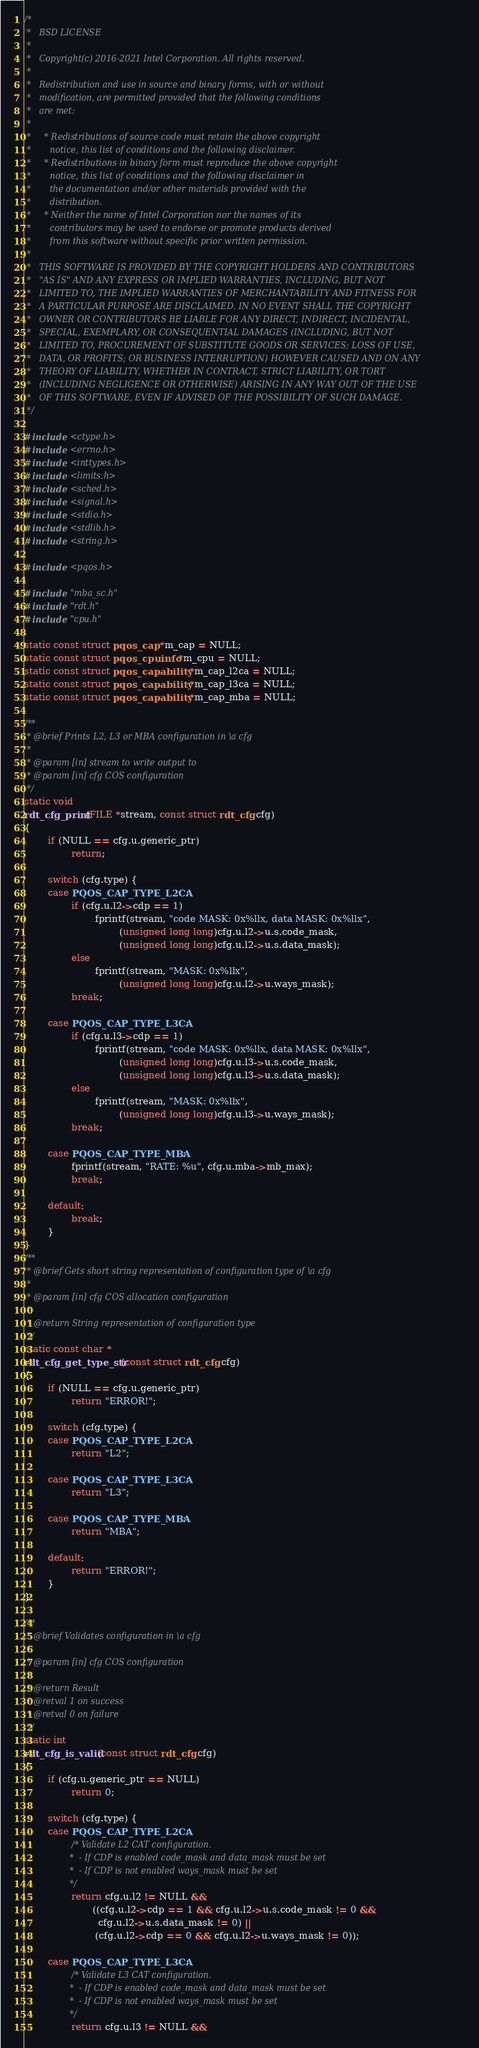Convert code to text. <code><loc_0><loc_0><loc_500><loc_500><_C_>/*
 *   BSD LICENSE
 *
 *   Copyright(c) 2016-2021 Intel Corporation. All rights reserved.
 *
 *   Redistribution and use in source and binary forms, with or without
 *   modification, are permitted provided that the following conditions
 *   are met:
 *
 *     * Redistributions of source code must retain the above copyright
 *       notice, this list of conditions and the following disclaimer.
 *     * Redistributions in binary form must reproduce the above copyright
 *       notice, this list of conditions and the following disclaimer in
 *       the documentation and/or other materials provided with the
 *       distribution.
 *     * Neither the name of Intel Corporation nor the names of its
 *       contributors may be used to endorse or promote products derived
 *       from this software without specific prior written permission.
 *
 *   THIS SOFTWARE IS PROVIDED BY THE COPYRIGHT HOLDERS AND CONTRIBUTORS
 *   "AS IS" AND ANY EXPRESS OR IMPLIED WARRANTIES, INCLUDING, BUT NOT
 *   LIMITED TO, THE IMPLIED WARRANTIES OF MERCHANTABILITY AND FITNESS FOR
 *   A PARTICULAR PURPOSE ARE DISCLAIMED. IN NO EVENT SHALL THE COPYRIGHT
 *   OWNER OR CONTRIBUTORS BE LIABLE FOR ANY DIRECT, INDIRECT, INCIDENTAL,
 *   SPECIAL, EXEMPLARY, OR CONSEQUENTIAL DAMAGES (INCLUDING, BUT NOT
 *   LIMITED TO, PROCUREMENT OF SUBSTITUTE GOODS OR SERVICES; LOSS OF USE,
 *   DATA, OR PROFITS; OR BUSINESS INTERRUPTION) HOWEVER CAUSED AND ON ANY
 *   THEORY OF LIABILITY, WHETHER IN CONTRACT, STRICT LIABILITY, OR TORT
 *   (INCLUDING NEGLIGENCE OR OTHERWISE) ARISING IN ANY WAY OUT OF THE USE
 *   OF THIS SOFTWARE, EVEN IF ADVISED OF THE POSSIBILITY OF SUCH DAMAGE.
 */

#include <ctype.h>
#include <errno.h>
#include <inttypes.h>
#include <limits.h>
#include <sched.h>
#include <signal.h>
#include <stdio.h>
#include <stdlib.h>
#include <string.h>

#include <pqos.h>

#include "mba_sc.h"
#include "rdt.h"
#include "cpu.h"

static const struct pqos_cap *m_cap = NULL;
static const struct pqos_cpuinfo *m_cpu = NULL;
static const struct pqos_capability *m_cap_l2ca = NULL;
static const struct pqos_capability *m_cap_l3ca = NULL;
static const struct pqos_capability *m_cap_mba = NULL;

/**
 * @brief Prints L2, L3 or MBA configuration in \a cfg
 *
 * @param [in] stream to write output to
 * @param [in] cfg COS configuration
 */
static void
rdt_cfg_print(FILE *stream, const struct rdt_cfg cfg)
{
        if (NULL == cfg.u.generic_ptr)
                return;

        switch (cfg.type) {
        case PQOS_CAP_TYPE_L2CA:
                if (cfg.u.l2->cdp == 1)
                        fprintf(stream, "code MASK: 0x%llx, data MASK: 0x%llx",
                                (unsigned long long)cfg.u.l2->u.s.code_mask,
                                (unsigned long long)cfg.u.l2->u.s.data_mask);
                else
                        fprintf(stream, "MASK: 0x%llx",
                                (unsigned long long)cfg.u.l2->u.ways_mask);
                break;

        case PQOS_CAP_TYPE_L3CA:
                if (cfg.u.l3->cdp == 1)
                        fprintf(stream, "code MASK: 0x%llx, data MASK: 0x%llx",
                                (unsigned long long)cfg.u.l3->u.s.code_mask,
                                (unsigned long long)cfg.u.l3->u.s.data_mask);
                else
                        fprintf(stream, "MASK: 0x%llx",
                                (unsigned long long)cfg.u.l3->u.ways_mask);
                break;

        case PQOS_CAP_TYPE_MBA:
                fprintf(stream, "RATE: %u", cfg.u.mba->mb_max);
                break;

        default:
                break;
        }
}
/**
 * @brief Gets short string representation of configuration type of \a cfg
 *
 * @param [in] cfg COS allocation configuration
 *
 * @return String representation of configuration type
 */
static const char *
rdt_cfg_get_type_str(const struct rdt_cfg cfg)
{
        if (NULL == cfg.u.generic_ptr)
                return "ERROR!";

        switch (cfg.type) {
        case PQOS_CAP_TYPE_L2CA:
                return "L2";

        case PQOS_CAP_TYPE_L3CA:
                return "L3";

        case PQOS_CAP_TYPE_MBA:
                return "MBA";

        default:
                return "ERROR!";
        }
}

/**
 * @brief Validates configuration in \a cfg
 *
 * @param [in] cfg COS configuration
 *
 * @return Result
 * @retval 1 on success
 * @retval 0 on failure
 */
static int
rdt_cfg_is_valid(const struct rdt_cfg cfg)
{
        if (cfg.u.generic_ptr == NULL)
                return 0;

        switch (cfg.type) {
        case PQOS_CAP_TYPE_L2CA:
                /* Validate L2 CAT configuration.
                 *  - If CDP is enabled code_mask and data_mask must be set
                 *  - If CDP is not enabled ways_mask must be set
                 */
                return cfg.u.l2 != NULL &&
                       ((cfg.u.l2->cdp == 1 && cfg.u.l2->u.s.code_mask != 0 &&
                         cfg.u.l2->u.s.data_mask != 0) ||
                        (cfg.u.l2->cdp == 0 && cfg.u.l2->u.ways_mask != 0));

        case PQOS_CAP_TYPE_L3CA:
                /* Validate L3 CAT configuration.
                 *  - If CDP is enabled code_mask and data_mask must be set
                 *  - If CDP is not enabled ways_mask must be set
                 */
                return cfg.u.l3 != NULL &&</code> 